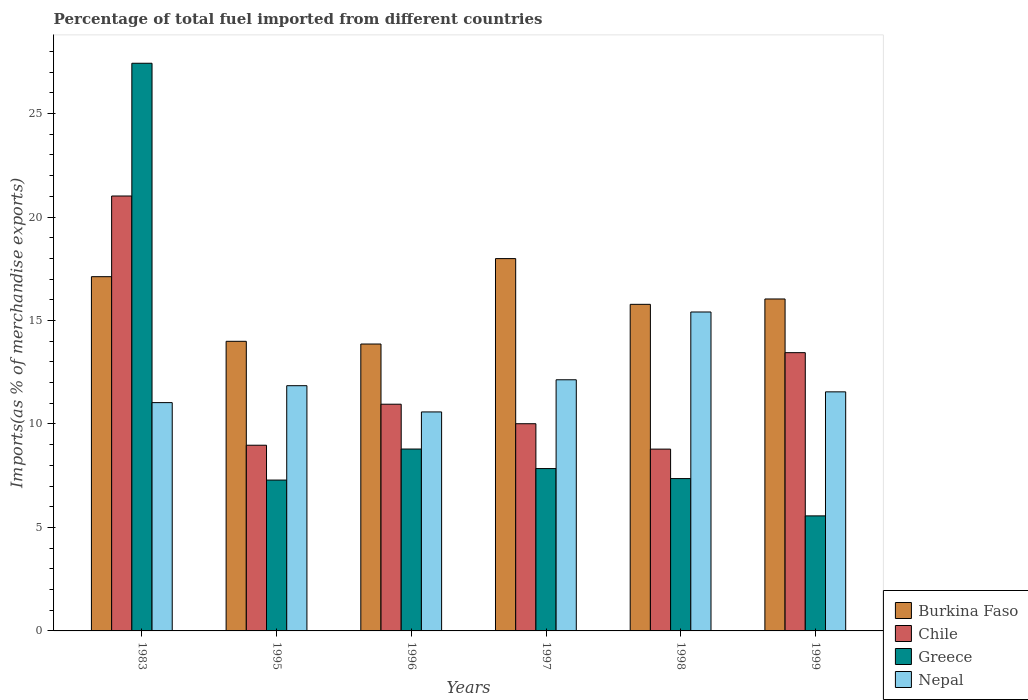How many groups of bars are there?
Ensure brevity in your answer.  6. Are the number of bars per tick equal to the number of legend labels?
Keep it short and to the point. Yes. Are the number of bars on each tick of the X-axis equal?
Your answer should be very brief. Yes. In how many cases, is the number of bars for a given year not equal to the number of legend labels?
Ensure brevity in your answer.  0. What is the percentage of imports to different countries in Burkina Faso in 1983?
Make the answer very short. 17.12. Across all years, what is the maximum percentage of imports to different countries in Burkina Faso?
Your answer should be compact. 17.99. Across all years, what is the minimum percentage of imports to different countries in Chile?
Offer a terse response. 8.79. In which year was the percentage of imports to different countries in Greece maximum?
Keep it short and to the point. 1983. What is the total percentage of imports to different countries in Greece in the graph?
Make the answer very short. 64.28. What is the difference between the percentage of imports to different countries in Chile in 1995 and that in 1996?
Ensure brevity in your answer.  -1.98. What is the difference between the percentage of imports to different countries in Nepal in 1996 and the percentage of imports to different countries in Chile in 1995?
Offer a terse response. 1.61. What is the average percentage of imports to different countries in Chile per year?
Provide a succinct answer. 12.2. In the year 1995, what is the difference between the percentage of imports to different countries in Greece and percentage of imports to different countries in Burkina Faso?
Make the answer very short. -6.71. What is the ratio of the percentage of imports to different countries in Greece in 1997 to that in 1999?
Offer a terse response. 1.41. Is the percentage of imports to different countries in Burkina Faso in 1983 less than that in 1999?
Provide a short and direct response. No. Is the difference between the percentage of imports to different countries in Greece in 1983 and 1995 greater than the difference between the percentage of imports to different countries in Burkina Faso in 1983 and 1995?
Your answer should be compact. Yes. What is the difference between the highest and the second highest percentage of imports to different countries in Greece?
Provide a succinct answer. 18.64. What is the difference between the highest and the lowest percentage of imports to different countries in Greece?
Your response must be concise. 21.87. What does the 4th bar from the left in 1999 represents?
Keep it short and to the point. Nepal. Is it the case that in every year, the sum of the percentage of imports to different countries in Burkina Faso and percentage of imports to different countries in Nepal is greater than the percentage of imports to different countries in Greece?
Your response must be concise. Yes. Are the values on the major ticks of Y-axis written in scientific E-notation?
Your answer should be very brief. No. Where does the legend appear in the graph?
Provide a short and direct response. Bottom right. What is the title of the graph?
Make the answer very short. Percentage of total fuel imported from different countries. Does "Sao Tome and Principe" appear as one of the legend labels in the graph?
Your answer should be compact. No. What is the label or title of the Y-axis?
Ensure brevity in your answer.  Imports(as % of merchandise exports). What is the Imports(as % of merchandise exports) of Burkina Faso in 1983?
Your answer should be very brief. 17.12. What is the Imports(as % of merchandise exports) of Chile in 1983?
Ensure brevity in your answer.  21.02. What is the Imports(as % of merchandise exports) in Greece in 1983?
Keep it short and to the point. 27.43. What is the Imports(as % of merchandise exports) in Nepal in 1983?
Give a very brief answer. 11.03. What is the Imports(as % of merchandise exports) of Burkina Faso in 1995?
Your answer should be compact. 14. What is the Imports(as % of merchandise exports) of Chile in 1995?
Make the answer very short. 8.97. What is the Imports(as % of merchandise exports) of Greece in 1995?
Your answer should be very brief. 7.29. What is the Imports(as % of merchandise exports) of Nepal in 1995?
Your answer should be very brief. 11.85. What is the Imports(as % of merchandise exports) of Burkina Faso in 1996?
Give a very brief answer. 13.86. What is the Imports(as % of merchandise exports) of Chile in 1996?
Offer a very short reply. 10.96. What is the Imports(as % of merchandise exports) of Greece in 1996?
Offer a very short reply. 8.79. What is the Imports(as % of merchandise exports) in Nepal in 1996?
Make the answer very short. 10.58. What is the Imports(as % of merchandise exports) in Burkina Faso in 1997?
Your answer should be very brief. 17.99. What is the Imports(as % of merchandise exports) of Chile in 1997?
Give a very brief answer. 10.01. What is the Imports(as % of merchandise exports) in Greece in 1997?
Give a very brief answer. 7.85. What is the Imports(as % of merchandise exports) in Nepal in 1997?
Keep it short and to the point. 12.14. What is the Imports(as % of merchandise exports) in Burkina Faso in 1998?
Keep it short and to the point. 15.78. What is the Imports(as % of merchandise exports) of Chile in 1998?
Make the answer very short. 8.79. What is the Imports(as % of merchandise exports) in Greece in 1998?
Provide a succinct answer. 7.36. What is the Imports(as % of merchandise exports) in Nepal in 1998?
Provide a succinct answer. 15.41. What is the Imports(as % of merchandise exports) in Burkina Faso in 1999?
Make the answer very short. 16.04. What is the Imports(as % of merchandise exports) of Chile in 1999?
Your answer should be compact. 13.45. What is the Imports(as % of merchandise exports) in Greece in 1999?
Keep it short and to the point. 5.56. What is the Imports(as % of merchandise exports) of Nepal in 1999?
Give a very brief answer. 11.55. Across all years, what is the maximum Imports(as % of merchandise exports) in Burkina Faso?
Offer a terse response. 17.99. Across all years, what is the maximum Imports(as % of merchandise exports) of Chile?
Your answer should be compact. 21.02. Across all years, what is the maximum Imports(as % of merchandise exports) in Greece?
Give a very brief answer. 27.43. Across all years, what is the maximum Imports(as % of merchandise exports) in Nepal?
Your answer should be compact. 15.41. Across all years, what is the minimum Imports(as % of merchandise exports) of Burkina Faso?
Make the answer very short. 13.86. Across all years, what is the minimum Imports(as % of merchandise exports) of Chile?
Provide a short and direct response. 8.79. Across all years, what is the minimum Imports(as % of merchandise exports) in Greece?
Offer a terse response. 5.56. Across all years, what is the minimum Imports(as % of merchandise exports) in Nepal?
Provide a short and direct response. 10.58. What is the total Imports(as % of merchandise exports) of Burkina Faso in the graph?
Make the answer very short. 94.8. What is the total Imports(as % of merchandise exports) in Chile in the graph?
Ensure brevity in your answer.  73.19. What is the total Imports(as % of merchandise exports) in Greece in the graph?
Your answer should be very brief. 64.28. What is the total Imports(as % of merchandise exports) of Nepal in the graph?
Offer a very short reply. 72.57. What is the difference between the Imports(as % of merchandise exports) of Burkina Faso in 1983 and that in 1995?
Ensure brevity in your answer.  3.12. What is the difference between the Imports(as % of merchandise exports) in Chile in 1983 and that in 1995?
Provide a succinct answer. 12.04. What is the difference between the Imports(as % of merchandise exports) of Greece in 1983 and that in 1995?
Make the answer very short. 20.14. What is the difference between the Imports(as % of merchandise exports) of Nepal in 1983 and that in 1995?
Keep it short and to the point. -0.82. What is the difference between the Imports(as % of merchandise exports) of Burkina Faso in 1983 and that in 1996?
Offer a terse response. 3.25. What is the difference between the Imports(as % of merchandise exports) of Chile in 1983 and that in 1996?
Keep it short and to the point. 10.06. What is the difference between the Imports(as % of merchandise exports) of Greece in 1983 and that in 1996?
Provide a succinct answer. 18.64. What is the difference between the Imports(as % of merchandise exports) of Nepal in 1983 and that in 1996?
Ensure brevity in your answer.  0.45. What is the difference between the Imports(as % of merchandise exports) in Burkina Faso in 1983 and that in 1997?
Offer a terse response. -0.87. What is the difference between the Imports(as % of merchandise exports) in Chile in 1983 and that in 1997?
Your answer should be very brief. 11. What is the difference between the Imports(as % of merchandise exports) of Greece in 1983 and that in 1997?
Your answer should be compact. 19.59. What is the difference between the Imports(as % of merchandise exports) of Nepal in 1983 and that in 1997?
Your answer should be compact. -1.1. What is the difference between the Imports(as % of merchandise exports) in Burkina Faso in 1983 and that in 1998?
Your response must be concise. 1.34. What is the difference between the Imports(as % of merchandise exports) in Chile in 1983 and that in 1998?
Offer a very short reply. 12.23. What is the difference between the Imports(as % of merchandise exports) of Greece in 1983 and that in 1998?
Your response must be concise. 20.07. What is the difference between the Imports(as % of merchandise exports) in Nepal in 1983 and that in 1998?
Make the answer very short. -4.38. What is the difference between the Imports(as % of merchandise exports) of Burkina Faso in 1983 and that in 1999?
Offer a very short reply. 1.08. What is the difference between the Imports(as % of merchandise exports) of Chile in 1983 and that in 1999?
Ensure brevity in your answer.  7.57. What is the difference between the Imports(as % of merchandise exports) in Greece in 1983 and that in 1999?
Ensure brevity in your answer.  21.87. What is the difference between the Imports(as % of merchandise exports) of Nepal in 1983 and that in 1999?
Your response must be concise. -0.52. What is the difference between the Imports(as % of merchandise exports) of Burkina Faso in 1995 and that in 1996?
Your answer should be compact. 0.13. What is the difference between the Imports(as % of merchandise exports) of Chile in 1995 and that in 1996?
Keep it short and to the point. -1.98. What is the difference between the Imports(as % of merchandise exports) in Greece in 1995 and that in 1996?
Ensure brevity in your answer.  -1.5. What is the difference between the Imports(as % of merchandise exports) of Nepal in 1995 and that in 1996?
Offer a terse response. 1.27. What is the difference between the Imports(as % of merchandise exports) in Burkina Faso in 1995 and that in 1997?
Give a very brief answer. -4. What is the difference between the Imports(as % of merchandise exports) of Chile in 1995 and that in 1997?
Keep it short and to the point. -1.04. What is the difference between the Imports(as % of merchandise exports) in Greece in 1995 and that in 1997?
Keep it short and to the point. -0.56. What is the difference between the Imports(as % of merchandise exports) of Nepal in 1995 and that in 1997?
Your answer should be very brief. -0.29. What is the difference between the Imports(as % of merchandise exports) in Burkina Faso in 1995 and that in 1998?
Ensure brevity in your answer.  -1.79. What is the difference between the Imports(as % of merchandise exports) of Chile in 1995 and that in 1998?
Make the answer very short. 0.19. What is the difference between the Imports(as % of merchandise exports) in Greece in 1995 and that in 1998?
Your response must be concise. -0.07. What is the difference between the Imports(as % of merchandise exports) in Nepal in 1995 and that in 1998?
Provide a succinct answer. -3.56. What is the difference between the Imports(as % of merchandise exports) in Burkina Faso in 1995 and that in 1999?
Provide a succinct answer. -2.05. What is the difference between the Imports(as % of merchandise exports) of Chile in 1995 and that in 1999?
Your response must be concise. -4.47. What is the difference between the Imports(as % of merchandise exports) of Greece in 1995 and that in 1999?
Ensure brevity in your answer.  1.73. What is the difference between the Imports(as % of merchandise exports) in Nepal in 1995 and that in 1999?
Your response must be concise. 0.3. What is the difference between the Imports(as % of merchandise exports) in Burkina Faso in 1996 and that in 1997?
Your response must be concise. -4.13. What is the difference between the Imports(as % of merchandise exports) in Chile in 1996 and that in 1997?
Your answer should be very brief. 0.94. What is the difference between the Imports(as % of merchandise exports) of Greece in 1996 and that in 1997?
Offer a very short reply. 0.94. What is the difference between the Imports(as % of merchandise exports) in Nepal in 1996 and that in 1997?
Provide a short and direct response. -1.55. What is the difference between the Imports(as % of merchandise exports) of Burkina Faso in 1996 and that in 1998?
Provide a succinct answer. -1.92. What is the difference between the Imports(as % of merchandise exports) in Chile in 1996 and that in 1998?
Make the answer very short. 2.17. What is the difference between the Imports(as % of merchandise exports) in Greece in 1996 and that in 1998?
Ensure brevity in your answer.  1.43. What is the difference between the Imports(as % of merchandise exports) of Nepal in 1996 and that in 1998?
Provide a succinct answer. -4.83. What is the difference between the Imports(as % of merchandise exports) of Burkina Faso in 1996 and that in 1999?
Offer a terse response. -2.18. What is the difference between the Imports(as % of merchandise exports) of Chile in 1996 and that in 1999?
Offer a terse response. -2.49. What is the difference between the Imports(as % of merchandise exports) in Greece in 1996 and that in 1999?
Provide a succinct answer. 3.23. What is the difference between the Imports(as % of merchandise exports) of Nepal in 1996 and that in 1999?
Offer a very short reply. -0.97. What is the difference between the Imports(as % of merchandise exports) of Burkina Faso in 1997 and that in 1998?
Your response must be concise. 2.21. What is the difference between the Imports(as % of merchandise exports) in Chile in 1997 and that in 1998?
Your answer should be compact. 1.23. What is the difference between the Imports(as % of merchandise exports) in Greece in 1997 and that in 1998?
Provide a succinct answer. 0.48. What is the difference between the Imports(as % of merchandise exports) of Nepal in 1997 and that in 1998?
Give a very brief answer. -3.28. What is the difference between the Imports(as % of merchandise exports) in Burkina Faso in 1997 and that in 1999?
Offer a very short reply. 1.95. What is the difference between the Imports(as % of merchandise exports) in Chile in 1997 and that in 1999?
Provide a succinct answer. -3.43. What is the difference between the Imports(as % of merchandise exports) in Greece in 1997 and that in 1999?
Ensure brevity in your answer.  2.29. What is the difference between the Imports(as % of merchandise exports) in Nepal in 1997 and that in 1999?
Ensure brevity in your answer.  0.58. What is the difference between the Imports(as % of merchandise exports) in Burkina Faso in 1998 and that in 1999?
Offer a terse response. -0.26. What is the difference between the Imports(as % of merchandise exports) in Chile in 1998 and that in 1999?
Give a very brief answer. -4.66. What is the difference between the Imports(as % of merchandise exports) in Greece in 1998 and that in 1999?
Your answer should be very brief. 1.8. What is the difference between the Imports(as % of merchandise exports) of Nepal in 1998 and that in 1999?
Provide a short and direct response. 3.86. What is the difference between the Imports(as % of merchandise exports) of Burkina Faso in 1983 and the Imports(as % of merchandise exports) of Chile in 1995?
Your answer should be very brief. 8.15. What is the difference between the Imports(as % of merchandise exports) of Burkina Faso in 1983 and the Imports(as % of merchandise exports) of Greece in 1995?
Provide a short and direct response. 9.83. What is the difference between the Imports(as % of merchandise exports) in Burkina Faso in 1983 and the Imports(as % of merchandise exports) in Nepal in 1995?
Ensure brevity in your answer.  5.27. What is the difference between the Imports(as % of merchandise exports) of Chile in 1983 and the Imports(as % of merchandise exports) of Greece in 1995?
Ensure brevity in your answer.  13.73. What is the difference between the Imports(as % of merchandise exports) in Chile in 1983 and the Imports(as % of merchandise exports) in Nepal in 1995?
Keep it short and to the point. 9.17. What is the difference between the Imports(as % of merchandise exports) of Greece in 1983 and the Imports(as % of merchandise exports) of Nepal in 1995?
Ensure brevity in your answer.  15.58. What is the difference between the Imports(as % of merchandise exports) of Burkina Faso in 1983 and the Imports(as % of merchandise exports) of Chile in 1996?
Give a very brief answer. 6.16. What is the difference between the Imports(as % of merchandise exports) in Burkina Faso in 1983 and the Imports(as % of merchandise exports) in Greece in 1996?
Offer a terse response. 8.33. What is the difference between the Imports(as % of merchandise exports) of Burkina Faso in 1983 and the Imports(as % of merchandise exports) of Nepal in 1996?
Ensure brevity in your answer.  6.54. What is the difference between the Imports(as % of merchandise exports) in Chile in 1983 and the Imports(as % of merchandise exports) in Greece in 1996?
Offer a terse response. 12.23. What is the difference between the Imports(as % of merchandise exports) of Chile in 1983 and the Imports(as % of merchandise exports) of Nepal in 1996?
Your answer should be very brief. 10.43. What is the difference between the Imports(as % of merchandise exports) of Greece in 1983 and the Imports(as % of merchandise exports) of Nepal in 1996?
Your response must be concise. 16.85. What is the difference between the Imports(as % of merchandise exports) of Burkina Faso in 1983 and the Imports(as % of merchandise exports) of Chile in 1997?
Make the answer very short. 7.11. What is the difference between the Imports(as % of merchandise exports) in Burkina Faso in 1983 and the Imports(as % of merchandise exports) in Greece in 1997?
Provide a short and direct response. 9.27. What is the difference between the Imports(as % of merchandise exports) of Burkina Faso in 1983 and the Imports(as % of merchandise exports) of Nepal in 1997?
Ensure brevity in your answer.  4.98. What is the difference between the Imports(as % of merchandise exports) of Chile in 1983 and the Imports(as % of merchandise exports) of Greece in 1997?
Your response must be concise. 13.17. What is the difference between the Imports(as % of merchandise exports) of Chile in 1983 and the Imports(as % of merchandise exports) of Nepal in 1997?
Provide a short and direct response. 8.88. What is the difference between the Imports(as % of merchandise exports) of Greece in 1983 and the Imports(as % of merchandise exports) of Nepal in 1997?
Offer a very short reply. 15.3. What is the difference between the Imports(as % of merchandise exports) in Burkina Faso in 1983 and the Imports(as % of merchandise exports) in Chile in 1998?
Offer a very short reply. 8.33. What is the difference between the Imports(as % of merchandise exports) in Burkina Faso in 1983 and the Imports(as % of merchandise exports) in Greece in 1998?
Provide a short and direct response. 9.76. What is the difference between the Imports(as % of merchandise exports) of Burkina Faso in 1983 and the Imports(as % of merchandise exports) of Nepal in 1998?
Your answer should be very brief. 1.71. What is the difference between the Imports(as % of merchandise exports) in Chile in 1983 and the Imports(as % of merchandise exports) in Greece in 1998?
Your answer should be very brief. 13.66. What is the difference between the Imports(as % of merchandise exports) of Chile in 1983 and the Imports(as % of merchandise exports) of Nepal in 1998?
Offer a terse response. 5.61. What is the difference between the Imports(as % of merchandise exports) in Greece in 1983 and the Imports(as % of merchandise exports) in Nepal in 1998?
Offer a very short reply. 12.02. What is the difference between the Imports(as % of merchandise exports) in Burkina Faso in 1983 and the Imports(as % of merchandise exports) in Chile in 1999?
Provide a short and direct response. 3.67. What is the difference between the Imports(as % of merchandise exports) of Burkina Faso in 1983 and the Imports(as % of merchandise exports) of Greece in 1999?
Ensure brevity in your answer.  11.56. What is the difference between the Imports(as % of merchandise exports) of Burkina Faso in 1983 and the Imports(as % of merchandise exports) of Nepal in 1999?
Make the answer very short. 5.57. What is the difference between the Imports(as % of merchandise exports) in Chile in 1983 and the Imports(as % of merchandise exports) in Greece in 1999?
Make the answer very short. 15.46. What is the difference between the Imports(as % of merchandise exports) of Chile in 1983 and the Imports(as % of merchandise exports) of Nepal in 1999?
Provide a short and direct response. 9.46. What is the difference between the Imports(as % of merchandise exports) in Greece in 1983 and the Imports(as % of merchandise exports) in Nepal in 1999?
Offer a terse response. 15.88. What is the difference between the Imports(as % of merchandise exports) of Burkina Faso in 1995 and the Imports(as % of merchandise exports) of Chile in 1996?
Your response must be concise. 3.04. What is the difference between the Imports(as % of merchandise exports) of Burkina Faso in 1995 and the Imports(as % of merchandise exports) of Greece in 1996?
Make the answer very short. 5.21. What is the difference between the Imports(as % of merchandise exports) in Burkina Faso in 1995 and the Imports(as % of merchandise exports) in Nepal in 1996?
Your answer should be very brief. 3.41. What is the difference between the Imports(as % of merchandise exports) of Chile in 1995 and the Imports(as % of merchandise exports) of Greece in 1996?
Your response must be concise. 0.18. What is the difference between the Imports(as % of merchandise exports) in Chile in 1995 and the Imports(as % of merchandise exports) in Nepal in 1996?
Provide a succinct answer. -1.61. What is the difference between the Imports(as % of merchandise exports) of Greece in 1995 and the Imports(as % of merchandise exports) of Nepal in 1996?
Offer a terse response. -3.29. What is the difference between the Imports(as % of merchandise exports) of Burkina Faso in 1995 and the Imports(as % of merchandise exports) of Chile in 1997?
Your answer should be compact. 3.98. What is the difference between the Imports(as % of merchandise exports) of Burkina Faso in 1995 and the Imports(as % of merchandise exports) of Greece in 1997?
Ensure brevity in your answer.  6.15. What is the difference between the Imports(as % of merchandise exports) in Burkina Faso in 1995 and the Imports(as % of merchandise exports) in Nepal in 1997?
Your answer should be compact. 1.86. What is the difference between the Imports(as % of merchandise exports) of Chile in 1995 and the Imports(as % of merchandise exports) of Greece in 1997?
Provide a short and direct response. 1.13. What is the difference between the Imports(as % of merchandise exports) in Chile in 1995 and the Imports(as % of merchandise exports) in Nepal in 1997?
Make the answer very short. -3.16. What is the difference between the Imports(as % of merchandise exports) in Greece in 1995 and the Imports(as % of merchandise exports) in Nepal in 1997?
Keep it short and to the point. -4.85. What is the difference between the Imports(as % of merchandise exports) in Burkina Faso in 1995 and the Imports(as % of merchandise exports) in Chile in 1998?
Your response must be concise. 5.21. What is the difference between the Imports(as % of merchandise exports) of Burkina Faso in 1995 and the Imports(as % of merchandise exports) of Greece in 1998?
Ensure brevity in your answer.  6.63. What is the difference between the Imports(as % of merchandise exports) in Burkina Faso in 1995 and the Imports(as % of merchandise exports) in Nepal in 1998?
Your response must be concise. -1.42. What is the difference between the Imports(as % of merchandise exports) in Chile in 1995 and the Imports(as % of merchandise exports) in Greece in 1998?
Provide a short and direct response. 1.61. What is the difference between the Imports(as % of merchandise exports) in Chile in 1995 and the Imports(as % of merchandise exports) in Nepal in 1998?
Provide a succinct answer. -6.44. What is the difference between the Imports(as % of merchandise exports) of Greece in 1995 and the Imports(as % of merchandise exports) of Nepal in 1998?
Make the answer very short. -8.12. What is the difference between the Imports(as % of merchandise exports) in Burkina Faso in 1995 and the Imports(as % of merchandise exports) in Chile in 1999?
Make the answer very short. 0.55. What is the difference between the Imports(as % of merchandise exports) of Burkina Faso in 1995 and the Imports(as % of merchandise exports) of Greece in 1999?
Offer a terse response. 8.44. What is the difference between the Imports(as % of merchandise exports) in Burkina Faso in 1995 and the Imports(as % of merchandise exports) in Nepal in 1999?
Ensure brevity in your answer.  2.44. What is the difference between the Imports(as % of merchandise exports) in Chile in 1995 and the Imports(as % of merchandise exports) in Greece in 1999?
Give a very brief answer. 3.42. What is the difference between the Imports(as % of merchandise exports) of Chile in 1995 and the Imports(as % of merchandise exports) of Nepal in 1999?
Offer a terse response. -2.58. What is the difference between the Imports(as % of merchandise exports) in Greece in 1995 and the Imports(as % of merchandise exports) in Nepal in 1999?
Your answer should be compact. -4.26. What is the difference between the Imports(as % of merchandise exports) of Burkina Faso in 1996 and the Imports(as % of merchandise exports) of Chile in 1997?
Your answer should be very brief. 3.85. What is the difference between the Imports(as % of merchandise exports) of Burkina Faso in 1996 and the Imports(as % of merchandise exports) of Greece in 1997?
Offer a terse response. 6.02. What is the difference between the Imports(as % of merchandise exports) in Burkina Faso in 1996 and the Imports(as % of merchandise exports) in Nepal in 1997?
Give a very brief answer. 1.73. What is the difference between the Imports(as % of merchandise exports) in Chile in 1996 and the Imports(as % of merchandise exports) in Greece in 1997?
Provide a succinct answer. 3.11. What is the difference between the Imports(as % of merchandise exports) of Chile in 1996 and the Imports(as % of merchandise exports) of Nepal in 1997?
Your response must be concise. -1.18. What is the difference between the Imports(as % of merchandise exports) in Greece in 1996 and the Imports(as % of merchandise exports) in Nepal in 1997?
Keep it short and to the point. -3.35. What is the difference between the Imports(as % of merchandise exports) in Burkina Faso in 1996 and the Imports(as % of merchandise exports) in Chile in 1998?
Your answer should be very brief. 5.08. What is the difference between the Imports(as % of merchandise exports) of Burkina Faso in 1996 and the Imports(as % of merchandise exports) of Greece in 1998?
Provide a short and direct response. 6.5. What is the difference between the Imports(as % of merchandise exports) in Burkina Faso in 1996 and the Imports(as % of merchandise exports) in Nepal in 1998?
Ensure brevity in your answer.  -1.55. What is the difference between the Imports(as % of merchandise exports) in Chile in 1996 and the Imports(as % of merchandise exports) in Greece in 1998?
Provide a succinct answer. 3.59. What is the difference between the Imports(as % of merchandise exports) in Chile in 1996 and the Imports(as % of merchandise exports) in Nepal in 1998?
Provide a succinct answer. -4.46. What is the difference between the Imports(as % of merchandise exports) of Greece in 1996 and the Imports(as % of merchandise exports) of Nepal in 1998?
Provide a short and direct response. -6.62. What is the difference between the Imports(as % of merchandise exports) of Burkina Faso in 1996 and the Imports(as % of merchandise exports) of Chile in 1999?
Offer a very short reply. 0.42. What is the difference between the Imports(as % of merchandise exports) of Burkina Faso in 1996 and the Imports(as % of merchandise exports) of Greece in 1999?
Your answer should be compact. 8.31. What is the difference between the Imports(as % of merchandise exports) of Burkina Faso in 1996 and the Imports(as % of merchandise exports) of Nepal in 1999?
Give a very brief answer. 2.31. What is the difference between the Imports(as % of merchandise exports) in Chile in 1996 and the Imports(as % of merchandise exports) in Greece in 1999?
Your answer should be compact. 5.4. What is the difference between the Imports(as % of merchandise exports) in Chile in 1996 and the Imports(as % of merchandise exports) in Nepal in 1999?
Make the answer very short. -0.6. What is the difference between the Imports(as % of merchandise exports) of Greece in 1996 and the Imports(as % of merchandise exports) of Nepal in 1999?
Keep it short and to the point. -2.76. What is the difference between the Imports(as % of merchandise exports) in Burkina Faso in 1997 and the Imports(as % of merchandise exports) in Chile in 1998?
Give a very brief answer. 9.21. What is the difference between the Imports(as % of merchandise exports) of Burkina Faso in 1997 and the Imports(as % of merchandise exports) of Greece in 1998?
Make the answer very short. 10.63. What is the difference between the Imports(as % of merchandise exports) of Burkina Faso in 1997 and the Imports(as % of merchandise exports) of Nepal in 1998?
Your answer should be compact. 2.58. What is the difference between the Imports(as % of merchandise exports) in Chile in 1997 and the Imports(as % of merchandise exports) in Greece in 1998?
Your answer should be very brief. 2.65. What is the difference between the Imports(as % of merchandise exports) of Chile in 1997 and the Imports(as % of merchandise exports) of Nepal in 1998?
Offer a terse response. -5.4. What is the difference between the Imports(as % of merchandise exports) of Greece in 1997 and the Imports(as % of merchandise exports) of Nepal in 1998?
Keep it short and to the point. -7.57. What is the difference between the Imports(as % of merchandise exports) of Burkina Faso in 1997 and the Imports(as % of merchandise exports) of Chile in 1999?
Your response must be concise. 4.55. What is the difference between the Imports(as % of merchandise exports) in Burkina Faso in 1997 and the Imports(as % of merchandise exports) in Greece in 1999?
Your answer should be compact. 12.43. What is the difference between the Imports(as % of merchandise exports) in Burkina Faso in 1997 and the Imports(as % of merchandise exports) in Nepal in 1999?
Give a very brief answer. 6.44. What is the difference between the Imports(as % of merchandise exports) of Chile in 1997 and the Imports(as % of merchandise exports) of Greece in 1999?
Ensure brevity in your answer.  4.45. What is the difference between the Imports(as % of merchandise exports) in Chile in 1997 and the Imports(as % of merchandise exports) in Nepal in 1999?
Ensure brevity in your answer.  -1.54. What is the difference between the Imports(as % of merchandise exports) of Greece in 1997 and the Imports(as % of merchandise exports) of Nepal in 1999?
Give a very brief answer. -3.71. What is the difference between the Imports(as % of merchandise exports) in Burkina Faso in 1998 and the Imports(as % of merchandise exports) in Chile in 1999?
Give a very brief answer. 2.34. What is the difference between the Imports(as % of merchandise exports) of Burkina Faso in 1998 and the Imports(as % of merchandise exports) of Greece in 1999?
Ensure brevity in your answer.  10.22. What is the difference between the Imports(as % of merchandise exports) of Burkina Faso in 1998 and the Imports(as % of merchandise exports) of Nepal in 1999?
Provide a succinct answer. 4.23. What is the difference between the Imports(as % of merchandise exports) of Chile in 1998 and the Imports(as % of merchandise exports) of Greece in 1999?
Your response must be concise. 3.23. What is the difference between the Imports(as % of merchandise exports) of Chile in 1998 and the Imports(as % of merchandise exports) of Nepal in 1999?
Provide a succinct answer. -2.77. What is the difference between the Imports(as % of merchandise exports) of Greece in 1998 and the Imports(as % of merchandise exports) of Nepal in 1999?
Provide a succinct answer. -4.19. What is the average Imports(as % of merchandise exports) in Burkina Faso per year?
Keep it short and to the point. 15.8. What is the average Imports(as % of merchandise exports) of Chile per year?
Give a very brief answer. 12.2. What is the average Imports(as % of merchandise exports) of Greece per year?
Your answer should be very brief. 10.71. What is the average Imports(as % of merchandise exports) in Nepal per year?
Keep it short and to the point. 12.1. In the year 1983, what is the difference between the Imports(as % of merchandise exports) of Burkina Faso and Imports(as % of merchandise exports) of Chile?
Your response must be concise. -3.9. In the year 1983, what is the difference between the Imports(as % of merchandise exports) of Burkina Faso and Imports(as % of merchandise exports) of Greece?
Keep it short and to the point. -10.31. In the year 1983, what is the difference between the Imports(as % of merchandise exports) in Burkina Faso and Imports(as % of merchandise exports) in Nepal?
Give a very brief answer. 6.09. In the year 1983, what is the difference between the Imports(as % of merchandise exports) in Chile and Imports(as % of merchandise exports) in Greece?
Your answer should be very brief. -6.42. In the year 1983, what is the difference between the Imports(as % of merchandise exports) of Chile and Imports(as % of merchandise exports) of Nepal?
Make the answer very short. 9.98. In the year 1983, what is the difference between the Imports(as % of merchandise exports) of Greece and Imports(as % of merchandise exports) of Nepal?
Offer a very short reply. 16.4. In the year 1995, what is the difference between the Imports(as % of merchandise exports) of Burkina Faso and Imports(as % of merchandise exports) of Chile?
Your answer should be very brief. 5.02. In the year 1995, what is the difference between the Imports(as % of merchandise exports) in Burkina Faso and Imports(as % of merchandise exports) in Greece?
Offer a terse response. 6.71. In the year 1995, what is the difference between the Imports(as % of merchandise exports) of Burkina Faso and Imports(as % of merchandise exports) of Nepal?
Provide a short and direct response. 2.15. In the year 1995, what is the difference between the Imports(as % of merchandise exports) of Chile and Imports(as % of merchandise exports) of Greece?
Your answer should be compact. 1.68. In the year 1995, what is the difference between the Imports(as % of merchandise exports) in Chile and Imports(as % of merchandise exports) in Nepal?
Your answer should be compact. -2.88. In the year 1995, what is the difference between the Imports(as % of merchandise exports) in Greece and Imports(as % of merchandise exports) in Nepal?
Offer a terse response. -4.56. In the year 1996, what is the difference between the Imports(as % of merchandise exports) in Burkina Faso and Imports(as % of merchandise exports) in Chile?
Your response must be concise. 2.91. In the year 1996, what is the difference between the Imports(as % of merchandise exports) of Burkina Faso and Imports(as % of merchandise exports) of Greece?
Offer a terse response. 5.08. In the year 1996, what is the difference between the Imports(as % of merchandise exports) in Burkina Faso and Imports(as % of merchandise exports) in Nepal?
Keep it short and to the point. 3.28. In the year 1996, what is the difference between the Imports(as % of merchandise exports) of Chile and Imports(as % of merchandise exports) of Greece?
Give a very brief answer. 2.17. In the year 1996, what is the difference between the Imports(as % of merchandise exports) in Chile and Imports(as % of merchandise exports) in Nepal?
Make the answer very short. 0.37. In the year 1996, what is the difference between the Imports(as % of merchandise exports) of Greece and Imports(as % of merchandise exports) of Nepal?
Make the answer very short. -1.79. In the year 1997, what is the difference between the Imports(as % of merchandise exports) in Burkina Faso and Imports(as % of merchandise exports) in Chile?
Your answer should be compact. 7.98. In the year 1997, what is the difference between the Imports(as % of merchandise exports) of Burkina Faso and Imports(as % of merchandise exports) of Greece?
Your answer should be compact. 10.15. In the year 1997, what is the difference between the Imports(as % of merchandise exports) of Burkina Faso and Imports(as % of merchandise exports) of Nepal?
Your response must be concise. 5.86. In the year 1997, what is the difference between the Imports(as % of merchandise exports) in Chile and Imports(as % of merchandise exports) in Greece?
Your answer should be compact. 2.17. In the year 1997, what is the difference between the Imports(as % of merchandise exports) in Chile and Imports(as % of merchandise exports) in Nepal?
Your response must be concise. -2.12. In the year 1997, what is the difference between the Imports(as % of merchandise exports) in Greece and Imports(as % of merchandise exports) in Nepal?
Give a very brief answer. -4.29. In the year 1998, what is the difference between the Imports(as % of merchandise exports) of Burkina Faso and Imports(as % of merchandise exports) of Chile?
Offer a terse response. 7. In the year 1998, what is the difference between the Imports(as % of merchandise exports) of Burkina Faso and Imports(as % of merchandise exports) of Greece?
Make the answer very short. 8.42. In the year 1998, what is the difference between the Imports(as % of merchandise exports) in Burkina Faso and Imports(as % of merchandise exports) in Nepal?
Give a very brief answer. 0.37. In the year 1998, what is the difference between the Imports(as % of merchandise exports) of Chile and Imports(as % of merchandise exports) of Greece?
Make the answer very short. 1.42. In the year 1998, what is the difference between the Imports(as % of merchandise exports) in Chile and Imports(as % of merchandise exports) in Nepal?
Make the answer very short. -6.63. In the year 1998, what is the difference between the Imports(as % of merchandise exports) in Greece and Imports(as % of merchandise exports) in Nepal?
Provide a succinct answer. -8.05. In the year 1999, what is the difference between the Imports(as % of merchandise exports) of Burkina Faso and Imports(as % of merchandise exports) of Chile?
Offer a very short reply. 2.59. In the year 1999, what is the difference between the Imports(as % of merchandise exports) in Burkina Faso and Imports(as % of merchandise exports) in Greece?
Keep it short and to the point. 10.48. In the year 1999, what is the difference between the Imports(as % of merchandise exports) of Burkina Faso and Imports(as % of merchandise exports) of Nepal?
Offer a terse response. 4.49. In the year 1999, what is the difference between the Imports(as % of merchandise exports) in Chile and Imports(as % of merchandise exports) in Greece?
Keep it short and to the point. 7.89. In the year 1999, what is the difference between the Imports(as % of merchandise exports) in Chile and Imports(as % of merchandise exports) in Nepal?
Offer a very short reply. 1.89. In the year 1999, what is the difference between the Imports(as % of merchandise exports) of Greece and Imports(as % of merchandise exports) of Nepal?
Make the answer very short. -5.99. What is the ratio of the Imports(as % of merchandise exports) in Burkina Faso in 1983 to that in 1995?
Give a very brief answer. 1.22. What is the ratio of the Imports(as % of merchandise exports) in Chile in 1983 to that in 1995?
Your answer should be compact. 2.34. What is the ratio of the Imports(as % of merchandise exports) of Greece in 1983 to that in 1995?
Offer a very short reply. 3.76. What is the ratio of the Imports(as % of merchandise exports) in Nepal in 1983 to that in 1995?
Offer a terse response. 0.93. What is the ratio of the Imports(as % of merchandise exports) in Burkina Faso in 1983 to that in 1996?
Provide a short and direct response. 1.23. What is the ratio of the Imports(as % of merchandise exports) of Chile in 1983 to that in 1996?
Provide a short and direct response. 1.92. What is the ratio of the Imports(as % of merchandise exports) in Greece in 1983 to that in 1996?
Ensure brevity in your answer.  3.12. What is the ratio of the Imports(as % of merchandise exports) of Nepal in 1983 to that in 1996?
Provide a succinct answer. 1.04. What is the ratio of the Imports(as % of merchandise exports) of Burkina Faso in 1983 to that in 1997?
Offer a very short reply. 0.95. What is the ratio of the Imports(as % of merchandise exports) of Chile in 1983 to that in 1997?
Keep it short and to the point. 2.1. What is the ratio of the Imports(as % of merchandise exports) in Greece in 1983 to that in 1997?
Make the answer very short. 3.5. What is the ratio of the Imports(as % of merchandise exports) in Nepal in 1983 to that in 1997?
Offer a terse response. 0.91. What is the ratio of the Imports(as % of merchandise exports) in Burkina Faso in 1983 to that in 1998?
Provide a succinct answer. 1.08. What is the ratio of the Imports(as % of merchandise exports) in Chile in 1983 to that in 1998?
Make the answer very short. 2.39. What is the ratio of the Imports(as % of merchandise exports) of Greece in 1983 to that in 1998?
Offer a terse response. 3.73. What is the ratio of the Imports(as % of merchandise exports) of Nepal in 1983 to that in 1998?
Make the answer very short. 0.72. What is the ratio of the Imports(as % of merchandise exports) of Burkina Faso in 1983 to that in 1999?
Make the answer very short. 1.07. What is the ratio of the Imports(as % of merchandise exports) of Chile in 1983 to that in 1999?
Make the answer very short. 1.56. What is the ratio of the Imports(as % of merchandise exports) of Greece in 1983 to that in 1999?
Provide a short and direct response. 4.93. What is the ratio of the Imports(as % of merchandise exports) in Nepal in 1983 to that in 1999?
Give a very brief answer. 0.95. What is the ratio of the Imports(as % of merchandise exports) of Burkina Faso in 1995 to that in 1996?
Make the answer very short. 1.01. What is the ratio of the Imports(as % of merchandise exports) in Chile in 1995 to that in 1996?
Provide a succinct answer. 0.82. What is the ratio of the Imports(as % of merchandise exports) in Greece in 1995 to that in 1996?
Provide a succinct answer. 0.83. What is the ratio of the Imports(as % of merchandise exports) in Nepal in 1995 to that in 1996?
Offer a very short reply. 1.12. What is the ratio of the Imports(as % of merchandise exports) in Burkina Faso in 1995 to that in 1997?
Give a very brief answer. 0.78. What is the ratio of the Imports(as % of merchandise exports) in Chile in 1995 to that in 1997?
Provide a succinct answer. 0.9. What is the ratio of the Imports(as % of merchandise exports) in Greece in 1995 to that in 1997?
Offer a terse response. 0.93. What is the ratio of the Imports(as % of merchandise exports) in Nepal in 1995 to that in 1997?
Your response must be concise. 0.98. What is the ratio of the Imports(as % of merchandise exports) in Burkina Faso in 1995 to that in 1998?
Offer a terse response. 0.89. What is the ratio of the Imports(as % of merchandise exports) of Chile in 1995 to that in 1998?
Your answer should be very brief. 1.02. What is the ratio of the Imports(as % of merchandise exports) in Greece in 1995 to that in 1998?
Provide a short and direct response. 0.99. What is the ratio of the Imports(as % of merchandise exports) of Nepal in 1995 to that in 1998?
Your answer should be very brief. 0.77. What is the ratio of the Imports(as % of merchandise exports) of Burkina Faso in 1995 to that in 1999?
Make the answer very short. 0.87. What is the ratio of the Imports(as % of merchandise exports) of Chile in 1995 to that in 1999?
Give a very brief answer. 0.67. What is the ratio of the Imports(as % of merchandise exports) in Greece in 1995 to that in 1999?
Your response must be concise. 1.31. What is the ratio of the Imports(as % of merchandise exports) in Nepal in 1995 to that in 1999?
Make the answer very short. 1.03. What is the ratio of the Imports(as % of merchandise exports) in Burkina Faso in 1996 to that in 1997?
Provide a succinct answer. 0.77. What is the ratio of the Imports(as % of merchandise exports) in Chile in 1996 to that in 1997?
Offer a very short reply. 1.09. What is the ratio of the Imports(as % of merchandise exports) of Greece in 1996 to that in 1997?
Your response must be concise. 1.12. What is the ratio of the Imports(as % of merchandise exports) in Nepal in 1996 to that in 1997?
Your answer should be very brief. 0.87. What is the ratio of the Imports(as % of merchandise exports) of Burkina Faso in 1996 to that in 1998?
Offer a terse response. 0.88. What is the ratio of the Imports(as % of merchandise exports) in Chile in 1996 to that in 1998?
Offer a very short reply. 1.25. What is the ratio of the Imports(as % of merchandise exports) in Greece in 1996 to that in 1998?
Provide a succinct answer. 1.19. What is the ratio of the Imports(as % of merchandise exports) in Nepal in 1996 to that in 1998?
Offer a terse response. 0.69. What is the ratio of the Imports(as % of merchandise exports) in Burkina Faso in 1996 to that in 1999?
Provide a succinct answer. 0.86. What is the ratio of the Imports(as % of merchandise exports) of Chile in 1996 to that in 1999?
Your response must be concise. 0.81. What is the ratio of the Imports(as % of merchandise exports) in Greece in 1996 to that in 1999?
Provide a succinct answer. 1.58. What is the ratio of the Imports(as % of merchandise exports) of Nepal in 1996 to that in 1999?
Ensure brevity in your answer.  0.92. What is the ratio of the Imports(as % of merchandise exports) in Burkina Faso in 1997 to that in 1998?
Your answer should be compact. 1.14. What is the ratio of the Imports(as % of merchandise exports) in Chile in 1997 to that in 1998?
Ensure brevity in your answer.  1.14. What is the ratio of the Imports(as % of merchandise exports) in Greece in 1997 to that in 1998?
Ensure brevity in your answer.  1.07. What is the ratio of the Imports(as % of merchandise exports) in Nepal in 1997 to that in 1998?
Offer a very short reply. 0.79. What is the ratio of the Imports(as % of merchandise exports) in Burkina Faso in 1997 to that in 1999?
Keep it short and to the point. 1.12. What is the ratio of the Imports(as % of merchandise exports) in Chile in 1997 to that in 1999?
Give a very brief answer. 0.74. What is the ratio of the Imports(as % of merchandise exports) of Greece in 1997 to that in 1999?
Your answer should be very brief. 1.41. What is the ratio of the Imports(as % of merchandise exports) in Nepal in 1997 to that in 1999?
Provide a succinct answer. 1.05. What is the ratio of the Imports(as % of merchandise exports) in Burkina Faso in 1998 to that in 1999?
Make the answer very short. 0.98. What is the ratio of the Imports(as % of merchandise exports) in Chile in 1998 to that in 1999?
Make the answer very short. 0.65. What is the ratio of the Imports(as % of merchandise exports) in Greece in 1998 to that in 1999?
Give a very brief answer. 1.32. What is the ratio of the Imports(as % of merchandise exports) of Nepal in 1998 to that in 1999?
Provide a succinct answer. 1.33. What is the difference between the highest and the second highest Imports(as % of merchandise exports) in Burkina Faso?
Your answer should be compact. 0.87. What is the difference between the highest and the second highest Imports(as % of merchandise exports) of Chile?
Offer a terse response. 7.57. What is the difference between the highest and the second highest Imports(as % of merchandise exports) of Greece?
Offer a very short reply. 18.64. What is the difference between the highest and the second highest Imports(as % of merchandise exports) in Nepal?
Give a very brief answer. 3.28. What is the difference between the highest and the lowest Imports(as % of merchandise exports) of Burkina Faso?
Provide a short and direct response. 4.13. What is the difference between the highest and the lowest Imports(as % of merchandise exports) in Chile?
Make the answer very short. 12.23. What is the difference between the highest and the lowest Imports(as % of merchandise exports) in Greece?
Your answer should be very brief. 21.87. What is the difference between the highest and the lowest Imports(as % of merchandise exports) in Nepal?
Offer a very short reply. 4.83. 